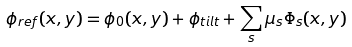<formula> <loc_0><loc_0><loc_500><loc_500>\phi _ { r e f } ( x , y ) = \phi _ { 0 } ( x , y ) + \phi _ { t i l t } + \sum _ { s } \mu _ { s } \Phi _ { s } ( x , y )</formula> 